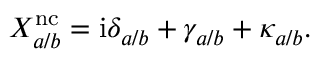Convert formula to latex. <formula><loc_0><loc_0><loc_500><loc_500>X _ { a / b } ^ { n c } = i \delta _ { a / b } + \gamma _ { a / b } + \kappa _ { a / b } .</formula> 